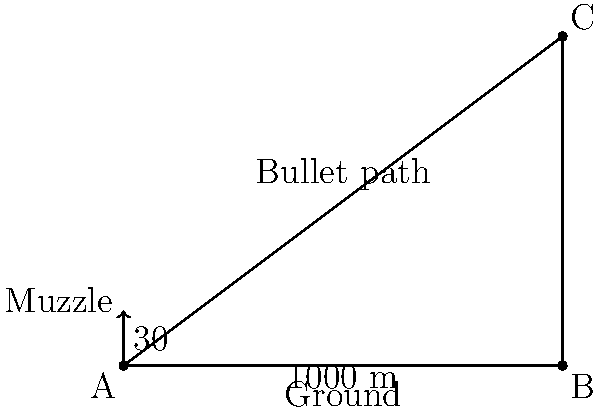A firearms enthusiast is testing the effective range of a new rifle. The bullet is fired from point A at a 30° angle to the horizontal. If the bullet hits the ground 1000 meters away at point B, what is the maximum height (point C) reached by the bullet? Round your answer to the nearest meter. Let's approach this step-by-step using trigonometry:

1) First, we need to identify the trigonometric ratios in this right-angled triangle ABC:
   - AB is the adjacent side to the 30° angle
   - BC is the opposite side to the 30° angle
   - AC is the hypotenuse

2) We know that:
   - The angle at A is 30°
   - AB (the range) is 1000 meters

3) To find BC (the maximum height), we can use the tangent ratio:

   $\tan 30° = \frac{BC}{AB}$

4) Rearranging this equation:

   $BC = AB \times \tan 30°$

5) We know that $\tan 30° = \frac{1}{\sqrt{3}} \approx 0.577$

6) Plugging in the values:

   $BC = 1000 \times 0.577 = 577$ meters

7) Rounding to the nearest meter:

   $BC \approx 577$ meters

Therefore, the maximum height reached by the bullet is approximately 577 meters.
Answer: 577 meters 